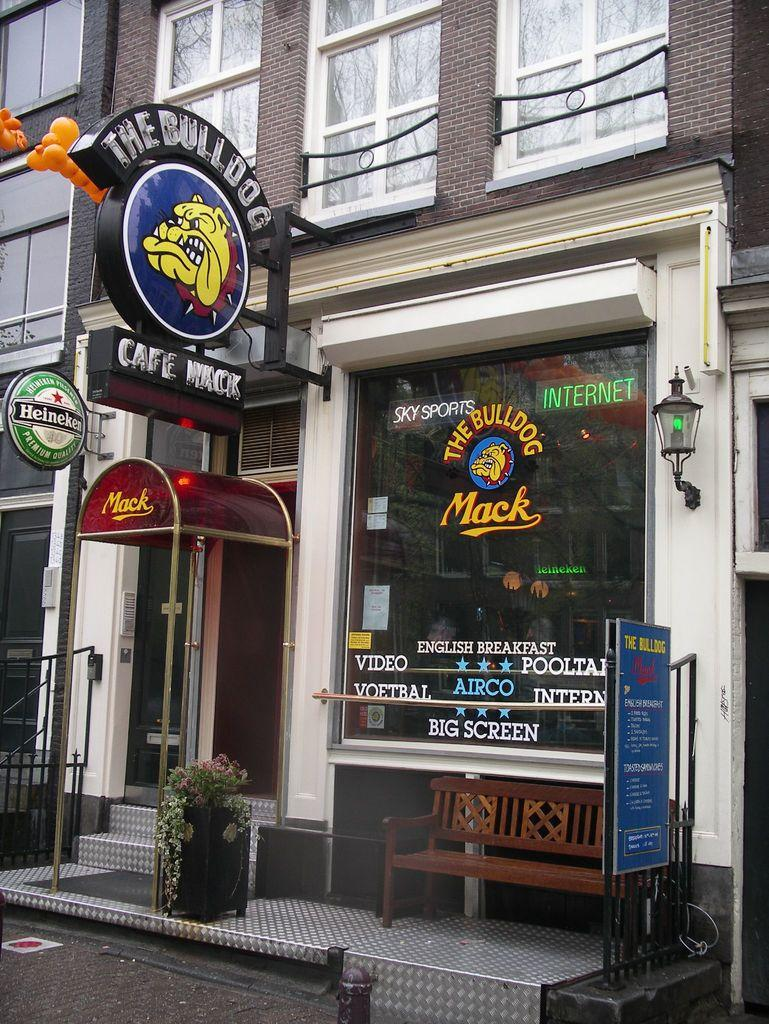What type of structure is visible in the image? There is a building in the image. What can be found outside the building? There is a chair, a light, and posters outside the building. Is there any greenery present in the image? Yes, there is a pot with a tree in the image. What time of day does the image appear to depict? The background of the image appears to be early morning. Can you tell me what type of locket is hanging from the tree in the image? There is no locket present in the image; it features a pot with a tree and no jewelry. Who is the expert in the image? There is no expert depicted in the image; it focuses on the building, outdoor items, and the tree. 